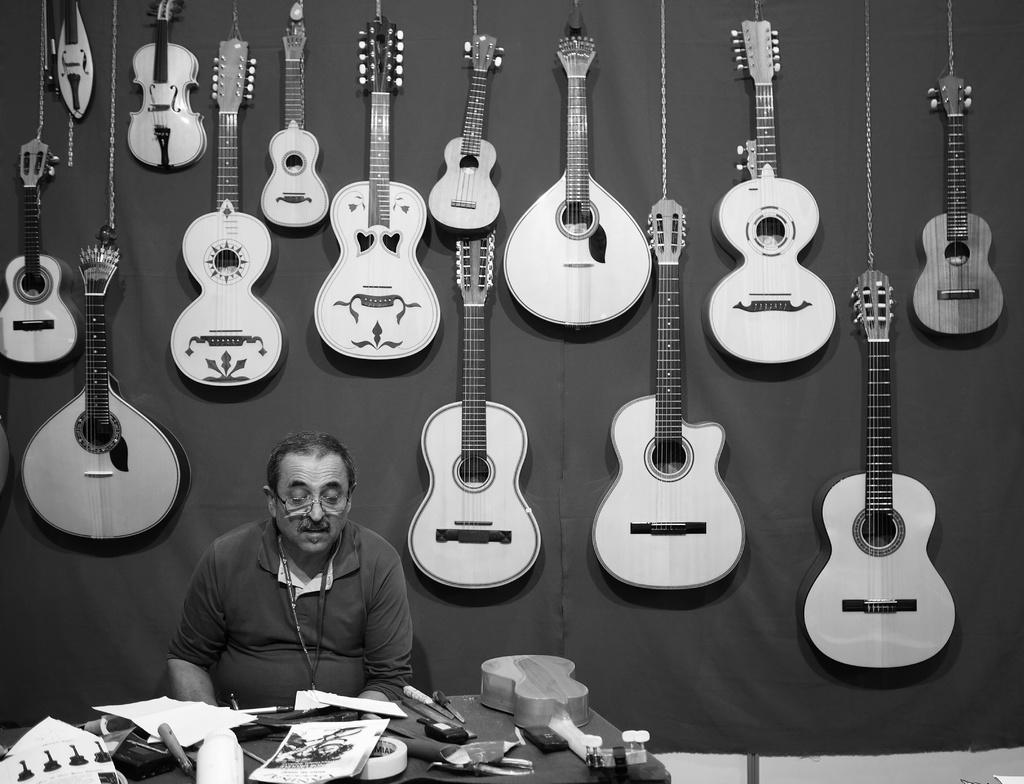What is the person in the image doing? There is a person sitting on a chair in the image. What can be seen in the image besides the person sitting on the chair? There is a musical instrument and a poster in the image. What is on the table in the image? There are papers and other things on the table in the image. What is visible in the background of the image? There are guitars and other musical instruments in the background of the image. What type of pear is being used as a plot device in the image? There is no pear or plot device present in the image. Can you describe the sea visible in the background of the image? There is no sea visible in the image; it features a person sitting on a chair, a musical instrument, a poster, papers, and other things on a table, as well as musical instruments in the background. 